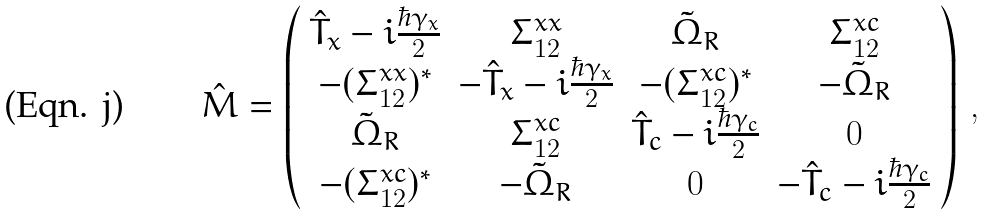<formula> <loc_0><loc_0><loc_500><loc_500>\hat { M } = \left ( \begin{array} { c c c c } \hat { T } _ { x } - i \frac { \hbar { \gamma } _ { x } } { 2 } & \Sigma ^ { x x } _ { 1 2 } & \tilde { \Omega } _ { R } & \Sigma ^ { x c } _ { 1 2 } \\ - ( \Sigma ^ { x x } _ { 1 2 } ) ^ { * } & - \hat { T } _ { x } - i \frac { \hbar { \gamma } _ { x } } { 2 } & - ( \Sigma ^ { x c } _ { 1 2 } ) ^ { * } & - \tilde { \Omega } _ { R } \\ \tilde { \Omega } _ { R } & \Sigma ^ { x c } _ { 1 2 } & \hat { T } _ { c } - i \frac { \hbar { \gamma } _ { c } } { 2 } & 0 \\ - ( \Sigma ^ { x c } _ { 1 2 } ) ^ { * } & - \tilde { \Omega } _ { R } & 0 & - \hat { T } _ { c } - i \frac { \hbar { \gamma } _ { c } } { 2 } \end{array} \right ) \, ,</formula> 